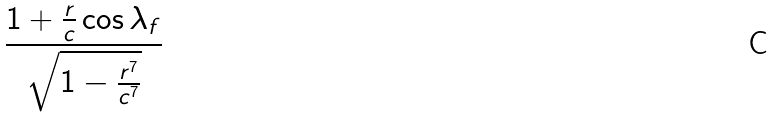Convert formula to latex. <formula><loc_0><loc_0><loc_500><loc_500>\frac { 1 + \frac { r } { c } \cos \lambda _ { f } } { \sqrt { 1 - \frac { r ^ { 7 } } { c ^ { 7 } } } }</formula> 